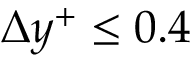Convert formula to latex. <formula><loc_0><loc_0><loc_500><loc_500>\Delta y ^ { + } \leq 0 . 4</formula> 